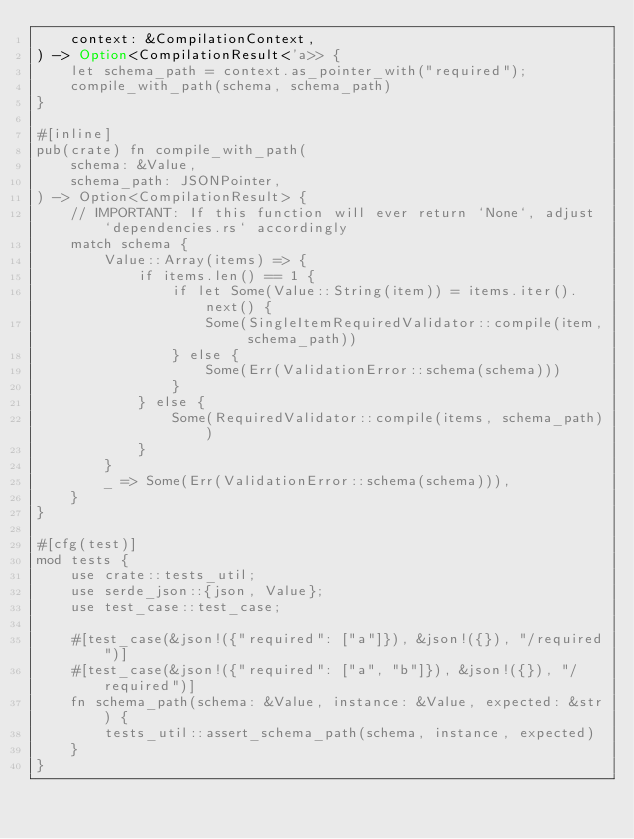Convert code to text. <code><loc_0><loc_0><loc_500><loc_500><_Rust_>    context: &CompilationContext,
) -> Option<CompilationResult<'a>> {
    let schema_path = context.as_pointer_with("required");
    compile_with_path(schema, schema_path)
}

#[inline]
pub(crate) fn compile_with_path(
    schema: &Value,
    schema_path: JSONPointer,
) -> Option<CompilationResult> {
    // IMPORTANT: If this function will ever return `None`, adjust `dependencies.rs` accordingly
    match schema {
        Value::Array(items) => {
            if items.len() == 1 {
                if let Some(Value::String(item)) = items.iter().next() {
                    Some(SingleItemRequiredValidator::compile(item, schema_path))
                } else {
                    Some(Err(ValidationError::schema(schema)))
                }
            } else {
                Some(RequiredValidator::compile(items, schema_path))
            }
        }
        _ => Some(Err(ValidationError::schema(schema))),
    }
}

#[cfg(test)]
mod tests {
    use crate::tests_util;
    use serde_json::{json, Value};
    use test_case::test_case;

    #[test_case(&json!({"required": ["a"]}), &json!({}), "/required")]
    #[test_case(&json!({"required": ["a", "b"]}), &json!({}), "/required")]
    fn schema_path(schema: &Value, instance: &Value, expected: &str) {
        tests_util::assert_schema_path(schema, instance, expected)
    }
}
</code> 